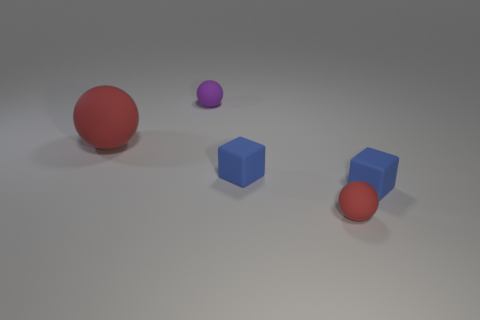Add 5 tiny blue matte cubes. How many objects exist? 10 Subtract all blocks. How many objects are left? 3 Add 2 red balls. How many red balls are left? 4 Add 1 purple rubber spheres. How many purple rubber spheres exist? 2 Subtract 0 purple cylinders. How many objects are left? 5 Subtract all purple spheres. Subtract all small rubber objects. How many objects are left? 0 